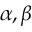<formula> <loc_0><loc_0><loc_500><loc_500>\alpha , \beta</formula> 